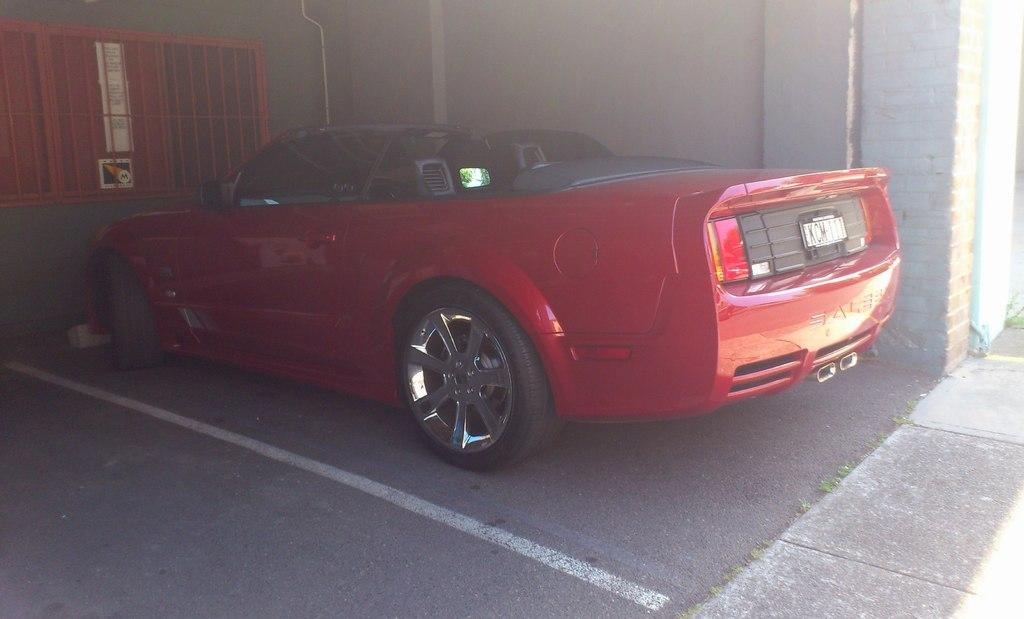What color is the car in the image? The car in the image is red. What is located behind the car in the image? There is a wall behind the car. What is located in front of the car in the image? There is a wall with windows in front of the car. What type of bread is being served at the party in the image? There is no party or bread present in the image; it only features a red car with walls behind and in front of it. 